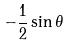Convert formula to latex. <formula><loc_0><loc_0><loc_500><loc_500>- \frac { 1 } { 2 } \sin \theta</formula> 